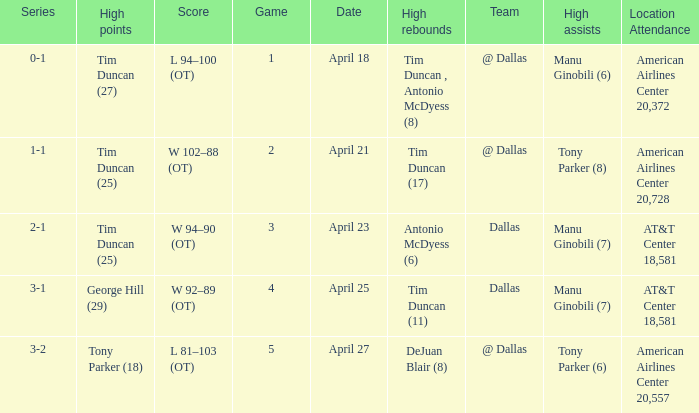Would you be able to parse every entry in this table? {'header': ['Series', 'High points', 'Score', 'Game', 'Date', 'High rebounds', 'Team', 'High assists', 'Location Attendance'], 'rows': [['0-1', 'Tim Duncan (27)', 'L 94–100 (OT)', '1', 'April 18', 'Tim Duncan , Antonio McDyess (8)', '@ Dallas', 'Manu Ginobili (6)', 'American Airlines Center 20,372'], ['1-1', 'Tim Duncan (25)', 'W 102–88 (OT)', '2', 'April 21', 'Tim Duncan (17)', '@ Dallas', 'Tony Parker (8)', 'American Airlines Center 20,728'], ['2-1', 'Tim Duncan (25)', 'W 94–90 (OT)', '3', 'April 23', 'Antonio McDyess (6)', 'Dallas', 'Manu Ginobili (7)', 'AT&T Center 18,581'], ['3-1', 'George Hill (29)', 'W 92–89 (OT)', '4', 'April 25', 'Tim Duncan (11)', 'Dallas', 'Manu Ginobili (7)', 'AT&T Center 18,581'], ['3-2', 'Tony Parker (18)', 'L 81–103 (OT)', '5', 'April 27', 'DeJuan Blair (8)', '@ Dallas', 'Tony Parker (6)', 'American Airlines Center 20,557']]} When 5 is the game who has the highest amount of points? Tony Parker (18). 